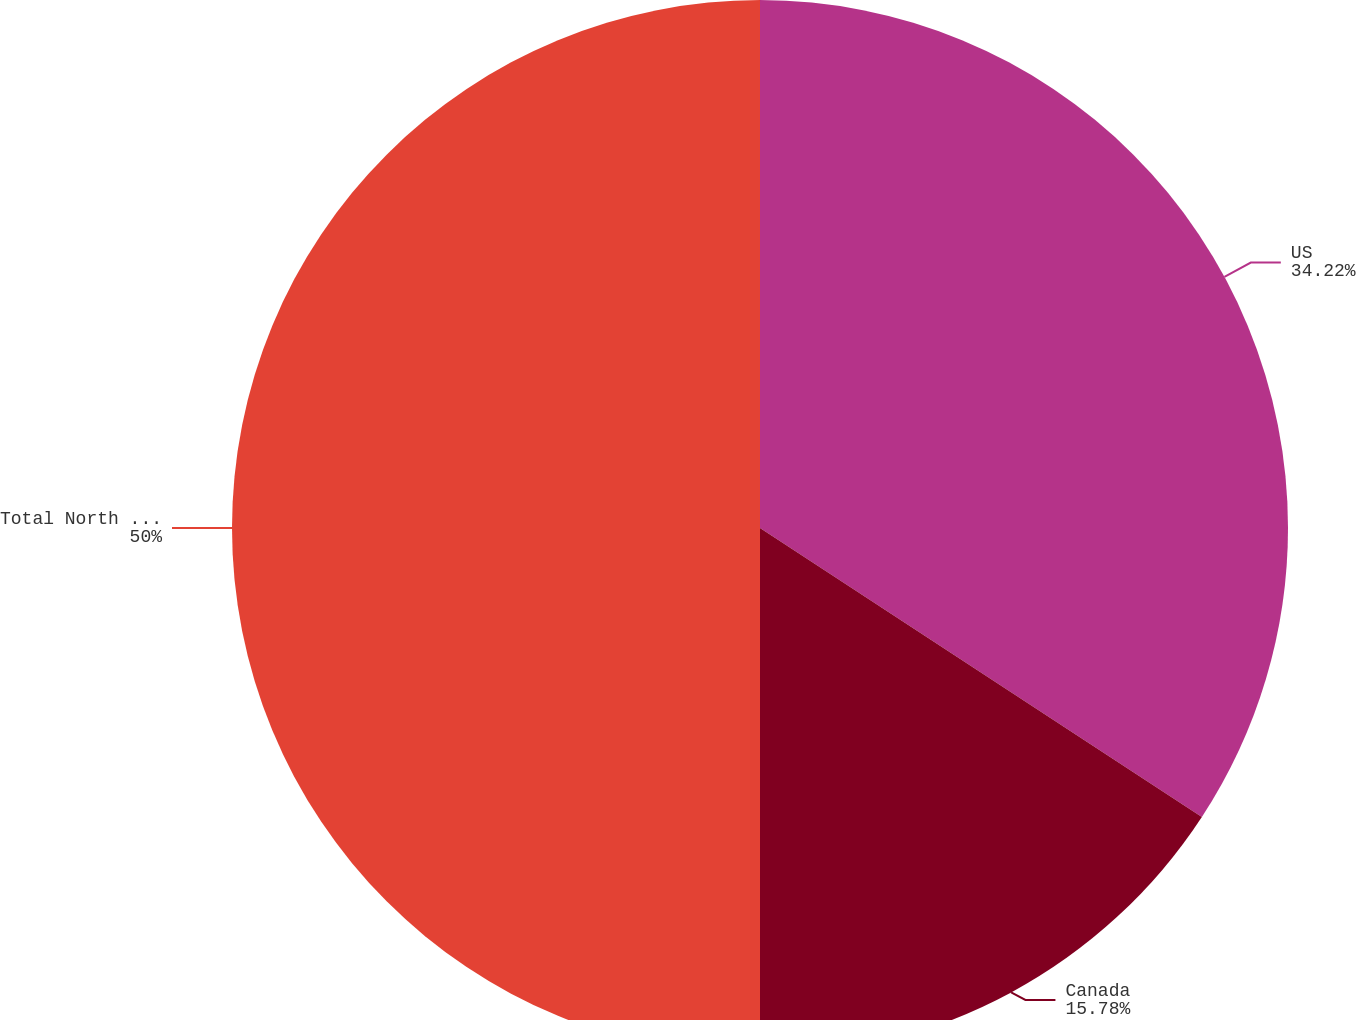<chart> <loc_0><loc_0><loc_500><loc_500><pie_chart><fcel>US<fcel>Canada<fcel>Total North America<nl><fcel>34.22%<fcel>15.78%<fcel>50.0%<nl></chart> 